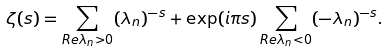Convert formula to latex. <formula><loc_0><loc_0><loc_500><loc_500>\zeta ( s ) = \sum _ { R e \lambda _ { n } > 0 } ( \lambda _ { n } ) ^ { - s } + \exp ( i \pi s ) \sum _ { R e \lambda _ { n } < 0 } ( - \lambda _ { n } ) ^ { - s } .</formula> 